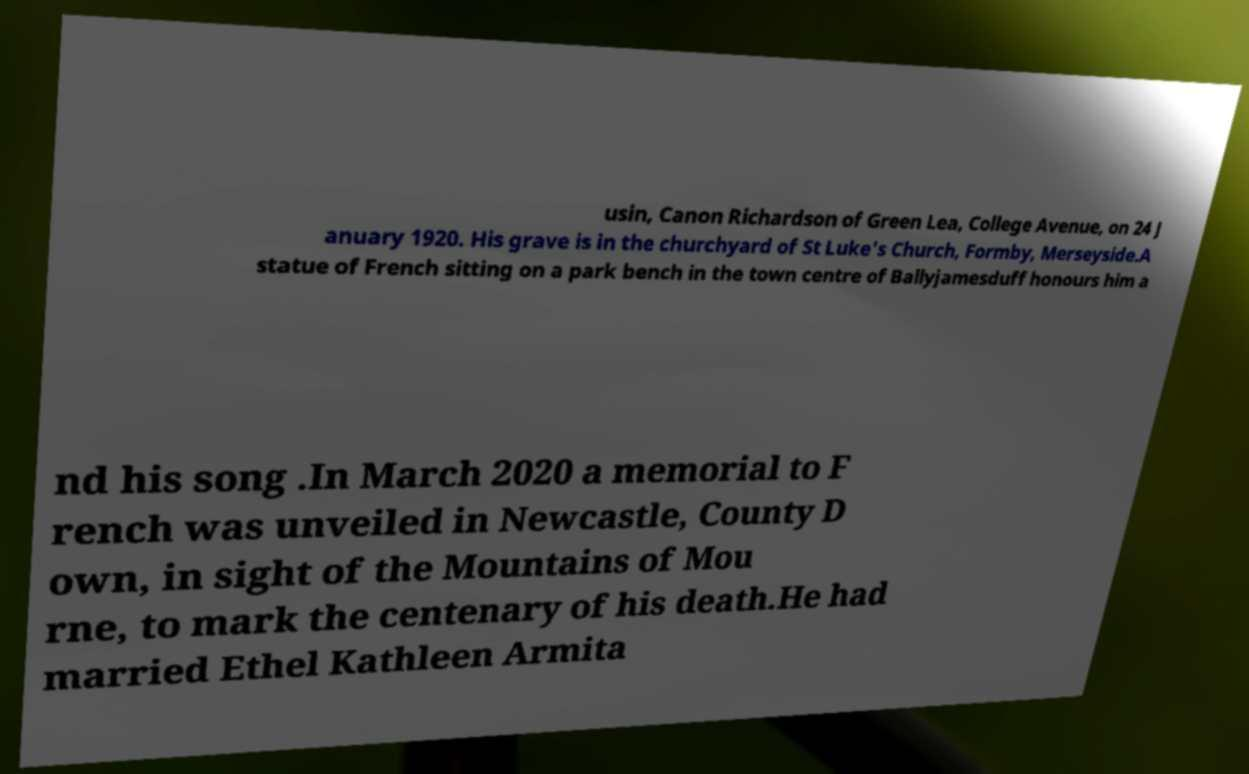Please read and relay the text visible in this image. What does it say? usin, Canon Richardson of Green Lea, College Avenue, on 24 J anuary 1920. His grave is in the churchyard of St Luke's Church, Formby, Merseyside.A statue of French sitting on a park bench in the town centre of Ballyjamesduff honours him a nd his song .In March 2020 a memorial to F rench was unveiled in Newcastle, County D own, in sight of the Mountains of Mou rne, to mark the centenary of his death.He had married Ethel Kathleen Armita 